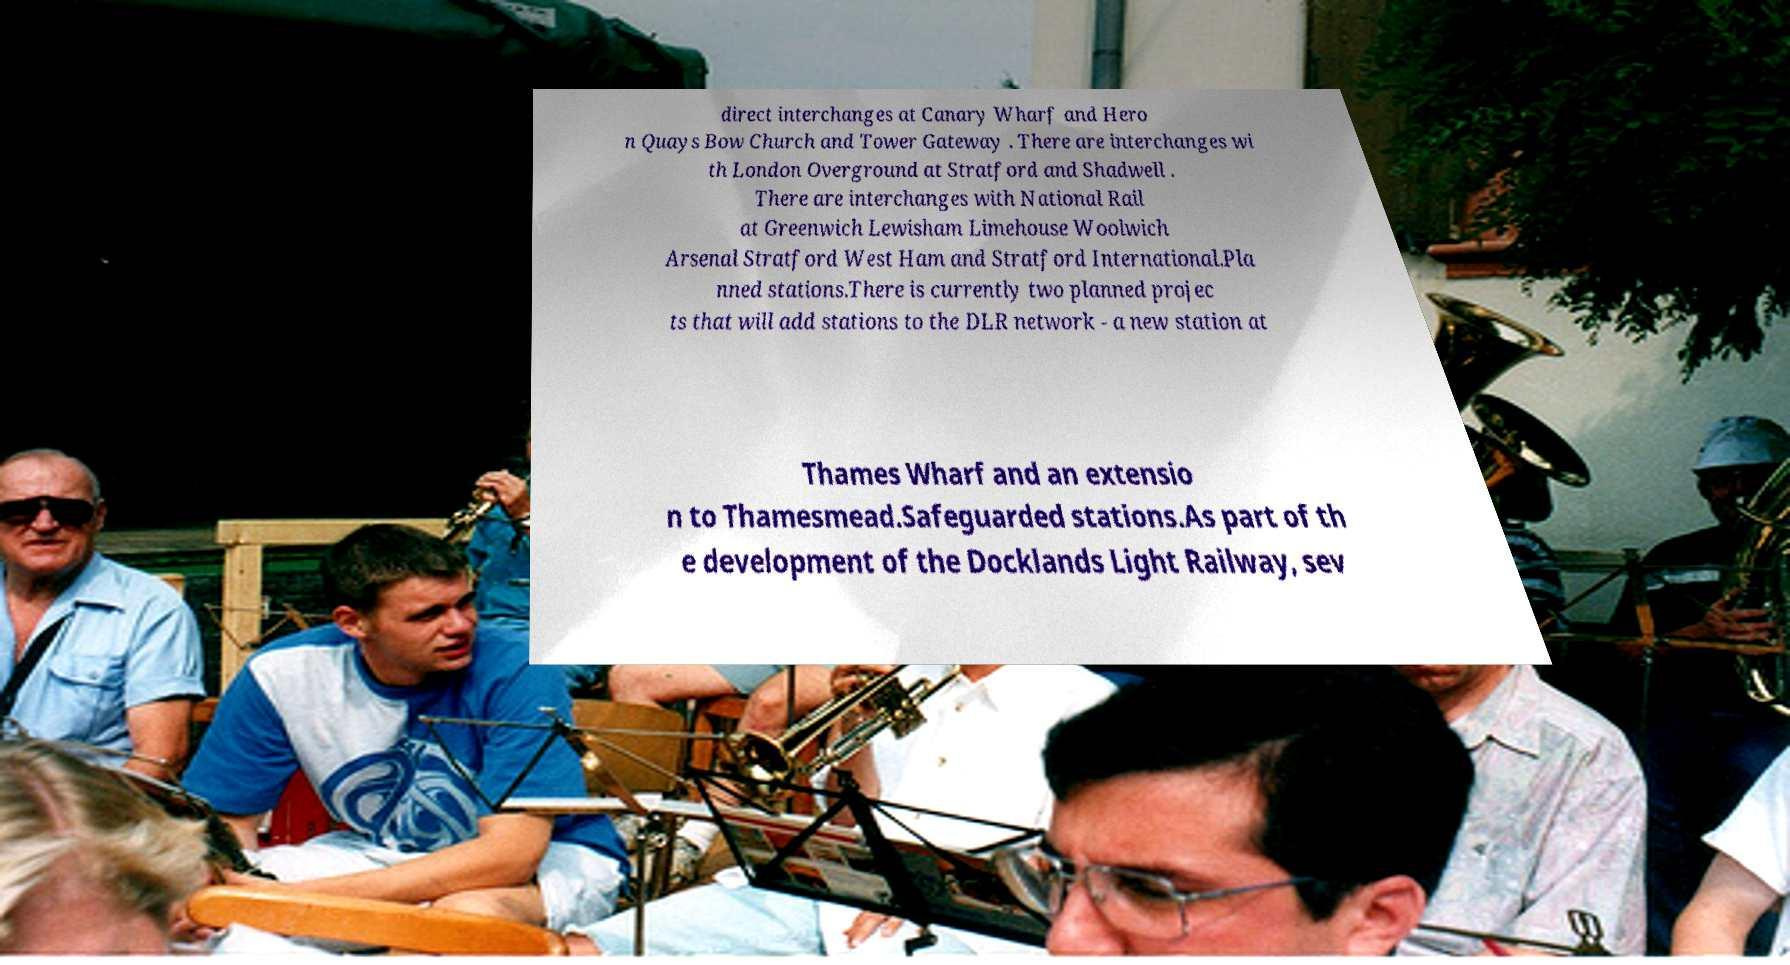I need the written content from this picture converted into text. Can you do that? direct interchanges at Canary Wharf and Hero n Quays Bow Church and Tower Gateway . There are interchanges wi th London Overground at Stratford and Shadwell . There are interchanges with National Rail at Greenwich Lewisham Limehouse Woolwich Arsenal Stratford West Ham and Stratford International.Pla nned stations.There is currently two planned projec ts that will add stations to the DLR network - a new station at Thames Wharf and an extensio n to Thamesmead.Safeguarded stations.As part of th e development of the Docklands Light Railway, sev 